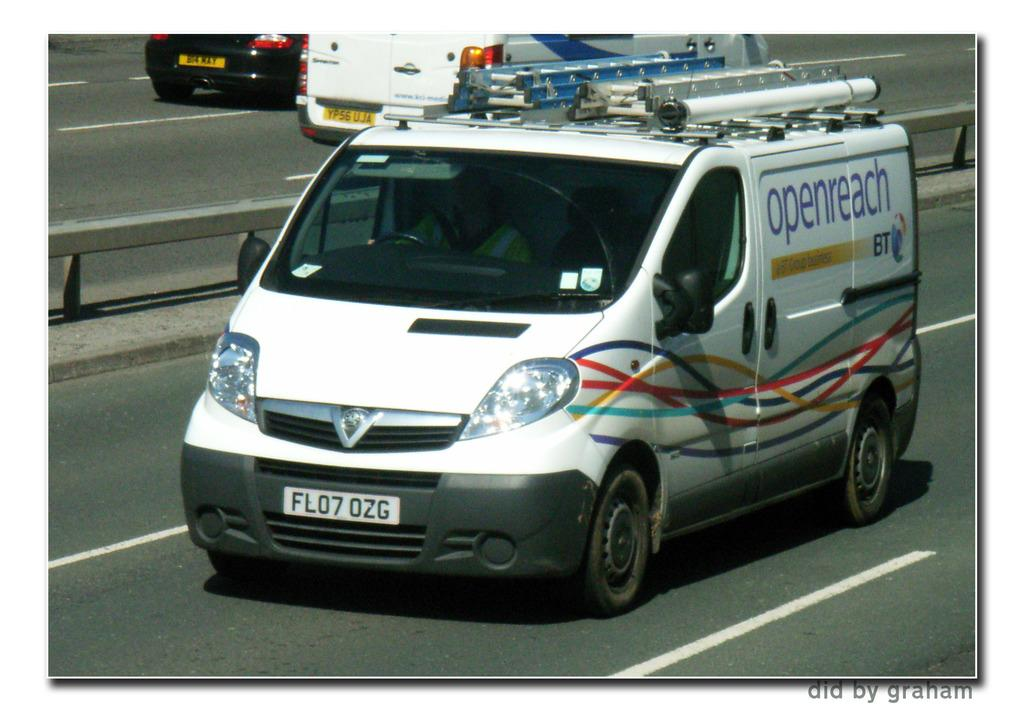What type of vehicle is in the image? There is a white van in the image. What is the van doing in the image? The van is moving on the road. What can be seen at the bottom of the image? There is a road at the bottom of the image. Are there any other vehicles visible in the image? Yes, there are two vehicles moving in the background. What type of cheese is being used to decorate the cabbage in the image? There is no cheese or cabbage present in the image; it features a white van moving on a road. How many babies are visible in the image? There are no babies visible in the image. 